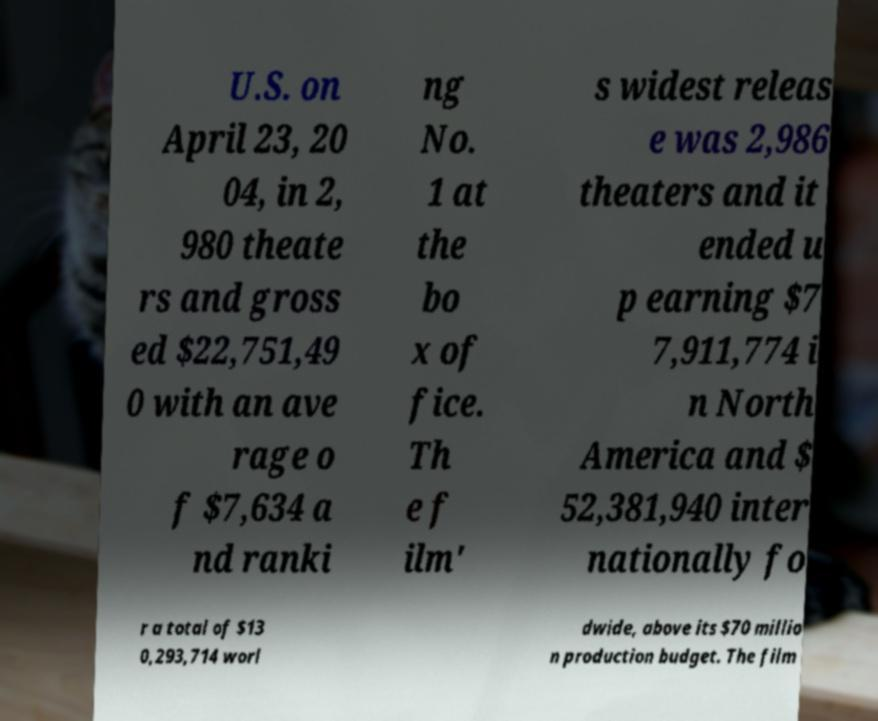There's text embedded in this image that I need extracted. Can you transcribe it verbatim? U.S. on April 23, 20 04, in 2, 980 theate rs and gross ed $22,751,49 0 with an ave rage o f $7,634 a nd ranki ng No. 1 at the bo x of fice. Th e f ilm' s widest releas e was 2,986 theaters and it ended u p earning $7 7,911,774 i n North America and $ 52,381,940 inter nationally fo r a total of $13 0,293,714 worl dwide, above its $70 millio n production budget. The film 